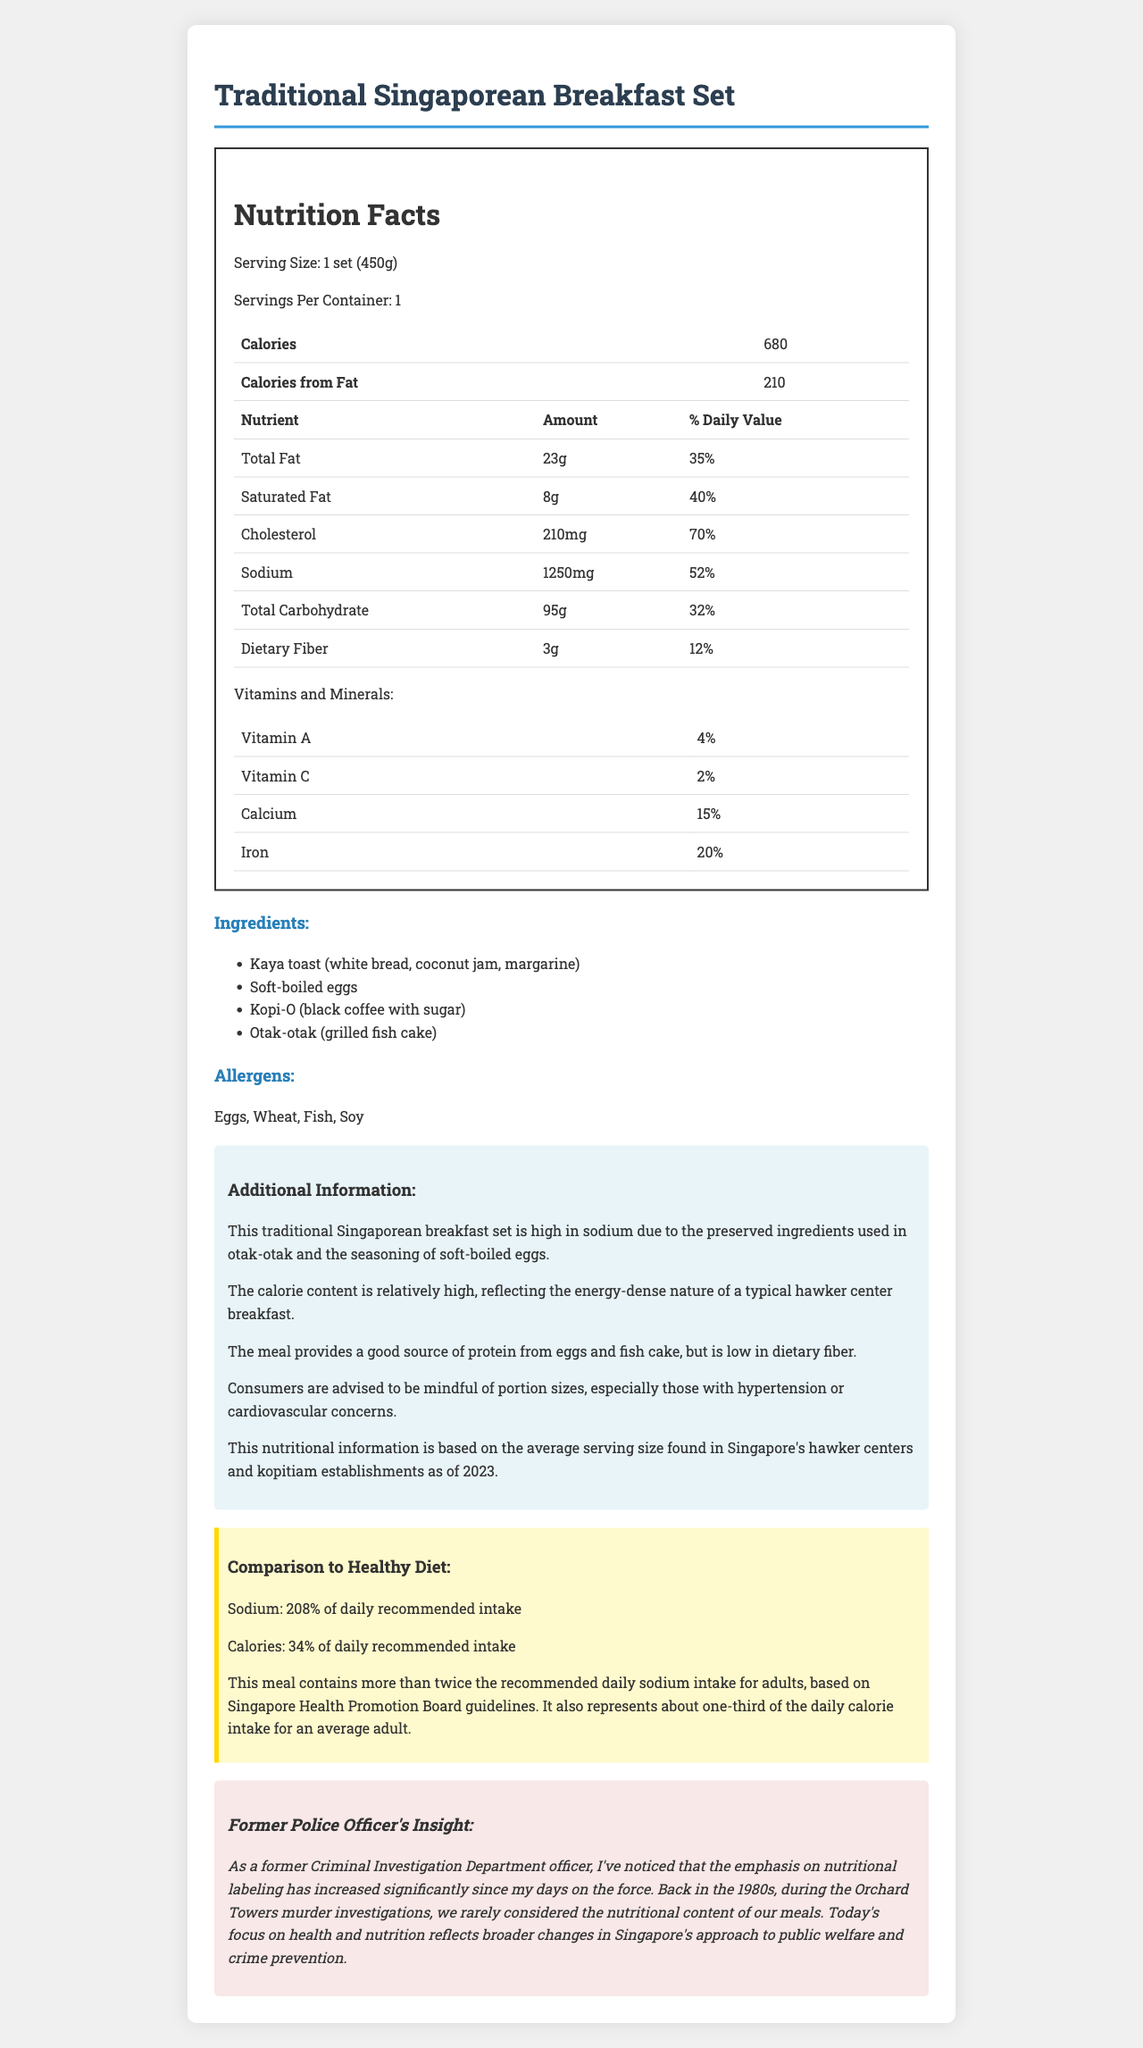what is the serving size of the Traditional Singaporean Breakfast Set? The serving size is specified in the document under the "Serving Size" section.
Answer: 1 set (450g) How many calories are in one Traditional Singaporean Breakfast Set? The calorie content is mentioned in the "Calories" section of the document.
Answer: 680 What is the amount of total fat in grams? The amount of total fat is shown in the "Total Fat" row under the "Nutrition Facts" table.
Answer: 23g What percentage of the daily recommended intake of sodium does this meal contain? This percentage is highlighted in the "Comparison to Healthy Diet" section.
Answer: 208% Can you list the allergens present in this breakfast set? The allergens are listed clearly under the "Allergens" section.
Answer: Eggs, Wheat, Fish, Soy How much protein is present in the Traditional Singaporean Breakfast Set? This information can be found in the "Protein" row within the nutrient table.
Answer: 25g What are the main ingredients in this breakfast set? A. Eggs, Toast, Coffee, Cake B. Kaya toast, Soft-boiled eggs, Kopi-O, Otak-otak C. Omelette, Toast, Tea, Pudding D. Kaya toast, Hard-boiled eggs, Tea, Otak-otak The main ingredients are listed under the "Ingredients" section.
Answer: B. Kaya toast, Soft-boiled eggs, Kopi-O, Otak-otak Which of the following nutrients is not present in significant quantity in the breakfast set? A. Cholesterol B. Dietary Fiber C. Calcium D. Sugars The "Sugars" row in the nutrient table shows that it has no specified daily value percentage, indicating it is not present in significant quantity.
Answer: D. Sugars Is this breakfast set high in sodium? The additional information explicitly states that this set is high in sodium.
Answer: Yes Summarize the main points of the Nutrition Facts Label for the Traditional Singaporean Breakfast Set. The summary covers the detailed breakdown of the meal's nutritional content, ingredients, allergens, additional health implications, and a comparison to dietary recommendations, providing a comprehensive overview of what the document contains.
Answer: The document details the nutritional information for a Traditional Singaporean Breakfast Set, including calorie content, fat, sodium, and other nutrients. The meal contains 680 calories, 23g of total fat, and a high sodium content at 1250mg, which is 208% of the daily recommended intake. It also lists the meal's ingredients, allergens, additional information on its high sodium and calorie content, and a comparison to a healthy diet. The document concludes with an insight from a former police officer regarding changes in nutritional awareness over the years. What is the exact amount of Vitamin C in milligrams in the meal? The document only provides the daily value percentage for Vitamin C but not the exact amount in milligrams.
Answer: Cannot be determined What is the daily value percentage for iron in the Traditional Singaporean Breakfast Set? This is shown in the "Vitamins and Minerals" section under the "Iron" row.
Answer: 20% 